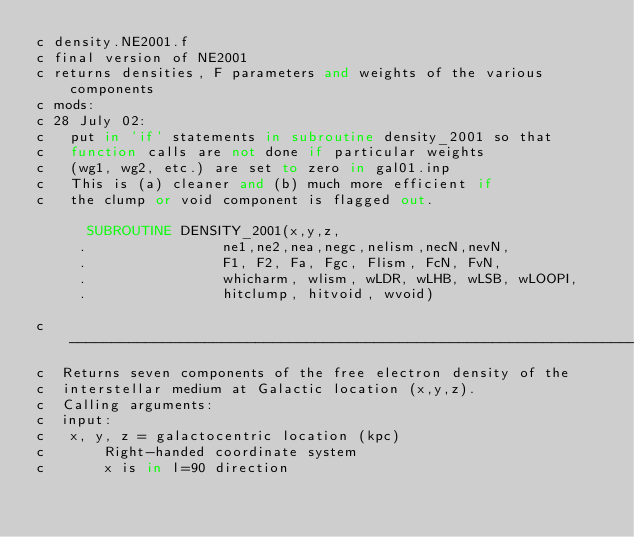<code> <loc_0><loc_0><loc_500><loc_500><_FORTRAN_>c density.NE2001.f
c final version of NE2001
c returns densities, F parameters and weights of the various components
c mods:
c 28 July 02:
c   put in 'if' statements in subroutine density_2001 so that
c	function calls are not done if particular weights
c	(wg1, wg2, etc.) are set to zero in gal01.inp
c	This is (a) cleaner and (b) much more efficient if
c	the clump or void component is flagged out.

      SUBROUTINE DENSITY_2001(x,y,z,
     .                ne1,ne2,nea,negc,nelism,necN,nevN,
     .                F1, F2, Fa, Fgc, Flism, FcN, FvN, 
     .                whicharm, wlism, wLDR, wLHB, wLSB, wLOOPI,
     .                hitclump, hitvoid, wvoid)

c----------------------------------------------------------------------------
c  Returns seven components of the free electron density of the 
c  interstellar medium at Galactic location (x,y,z).  
c  Calling arguments:
c  input:
c	x, y, z = galactocentric location (kpc)
c       Right-handed coordinate system
c       x is in l=90 direction</code> 